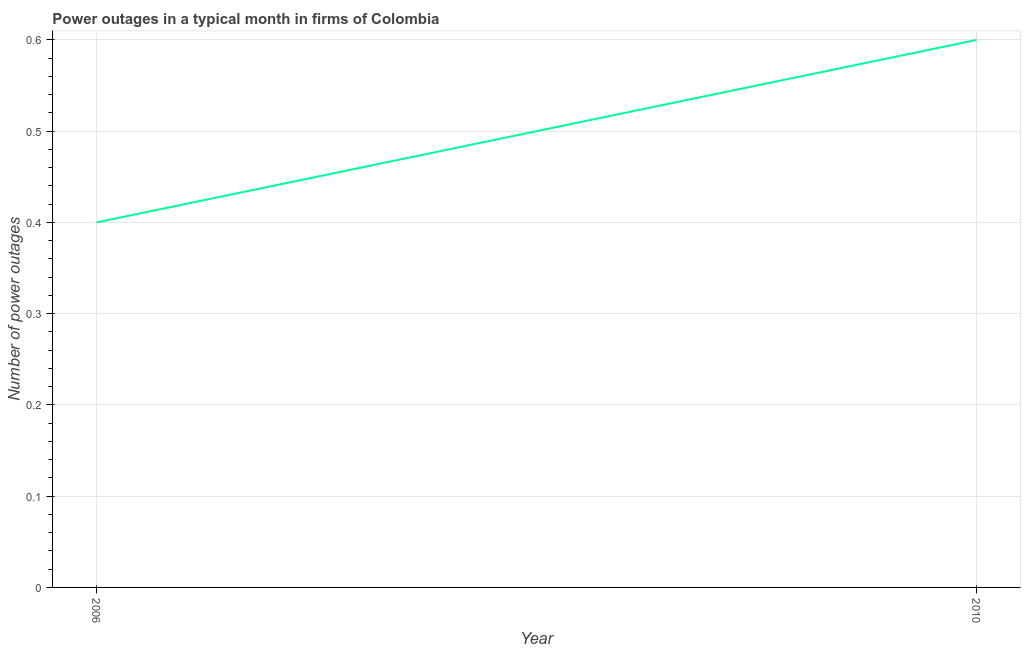What is the number of power outages in 2006?
Your answer should be very brief. 0.4. In which year was the number of power outages maximum?
Give a very brief answer. 2010. In which year was the number of power outages minimum?
Make the answer very short. 2006. What is the sum of the number of power outages?
Offer a very short reply. 1. What is the difference between the number of power outages in 2006 and 2010?
Your answer should be very brief. -0.2. What is the average number of power outages per year?
Give a very brief answer. 0.5. What is the median number of power outages?
Give a very brief answer. 0.5. What is the ratio of the number of power outages in 2006 to that in 2010?
Keep it short and to the point. 0.67. In how many years, is the number of power outages greater than the average number of power outages taken over all years?
Your answer should be compact. 1. Does the number of power outages monotonically increase over the years?
Give a very brief answer. Yes. What is the difference between two consecutive major ticks on the Y-axis?
Make the answer very short. 0.1. Are the values on the major ticks of Y-axis written in scientific E-notation?
Provide a succinct answer. No. What is the title of the graph?
Make the answer very short. Power outages in a typical month in firms of Colombia. What is the label or title of the X-axis?
Offer a very short reply. Year. What is the label or title of the Y-axis?
Ensure brevity in your answer.  Number of power outages. What is the Number of power outages in 2006?
Offer a very short reply. 0.4. What is the Number of power outages in 2010?
Offer a very short reply. 0.6. What is the ratio of the Number of power outages in 2006 to that in 2010?
Give a very brief answer. 0.67. 